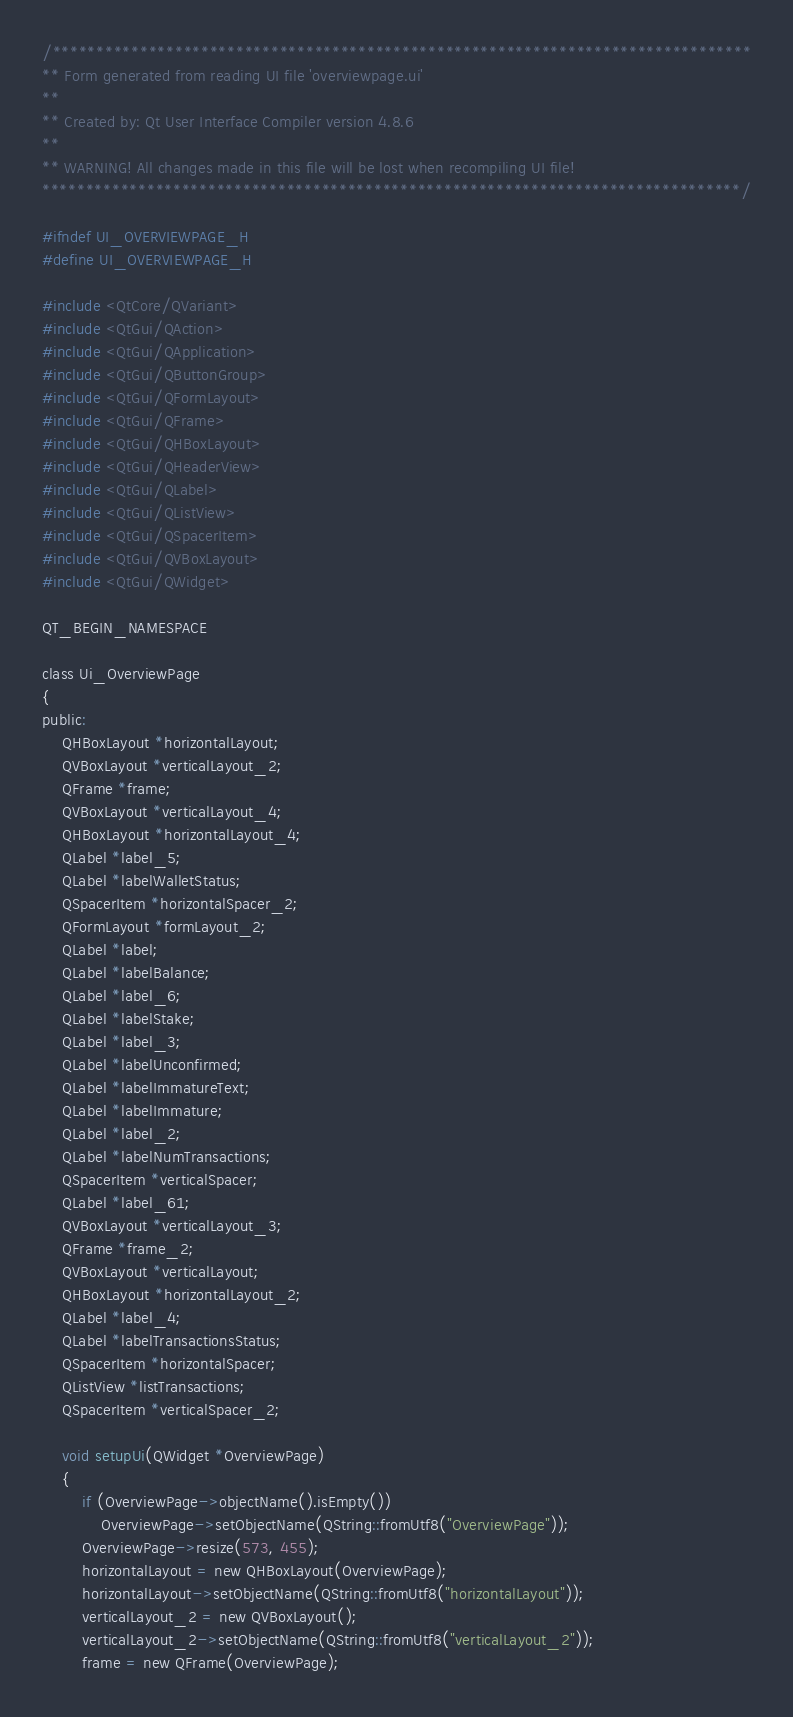Convert code to text. <code><loc_0><loc_0><loc_500><loc_500><_C_>/********************************************************************************
** Form generated from reading UI file 'overviewpage.ui'
**
** Created by: Qt User Interface Compiler version 4.8.6
**
** WARNING! All changes made in this file will be lost when recompiling UI file!
********************************************************************************/

#ifndef UI_OVERVIEWPAGE_H
#define UI_OVERVIEWPAGE_H

#include <QtCore/QVariant>
#include <QtGui/QAction>
#include <QtGui/QApplication>
#include <QtGui/QButtonGroup>
#include <QtGui/QFormLayout>
#include <QtGui/QFrame>
#include <QtGui/QHBoxLayout>
#include <QtGui/QHeaderView>
#include <QtGui/QLabel>
#include <QtGui/QListView>
#include <QtGui/QSpacerItem>
#include <QtGui/QVBoxLayout>
#include <QtGui/QWidget>

QT_BEGIN_NAMESPACE

class Ui_OverviewPage
{
public:
    QHBoxLayout *horizontalLayout;
    QVBoxLayout *verticalLayout_2;
    QFrame *frame;
    QVBoxLayout *verticalLayout_4;
    QHBoxLayout *horizontalLayout_4;
    QLabel *label_5;
    QLabel *labelWalletStatus;
    QSpacerItem *horizontalSpacer_2;
    QFormLayout *formLayout_2;
    QLabel *label;
    QLabel *labelBalance;
    QLabel *label_6;
    QLabel *labelStake;
    QLabel *label_3;
    QLabel *labelUnconfirmed;
    QLabel *labelImmatureText;
    QLabel *labelImmature;
    QLabel *label_2;
    QLabel *labelNumTransactions;
    QSpacerItem *verticalSpacer;
    QLabel *label_61;
    QVBoxLayout *verticalLayout_3;
    QFrame *frame_2;
    QVBoxLayout *verticalLayout;
    QHBoxLayout *horizontalLayout_2;
    QLabel *label_4;
    QLabel *labelTransactionsStatus;
    QSpacerItem *horizontalSpacer;
    QListView *listTransactions;
    QSpacerItem *verticalSpacer_2;

    void setupUi(QWidget *OverviewPage)
    {
        if (OverviewPage->objectName().isEmpty())
            OverviewPage->setObjectName(QString::fromUtf8("OverviewPage"));
        OverviewPage->resize(573, 455);
        horizontalLayout = new QHBoxLayout(OverviewPage);
        horizontalLayout->setObjectName(QString::fromUtf8("horizontalLayout"));
        verticalLayout_2 = new QVBoxLayout();
        verticalLayout_2->setObjectName(QString::fromUtf8("verticalLayout_2"));
        frame = new QFrame(OverviewPage);</code> 